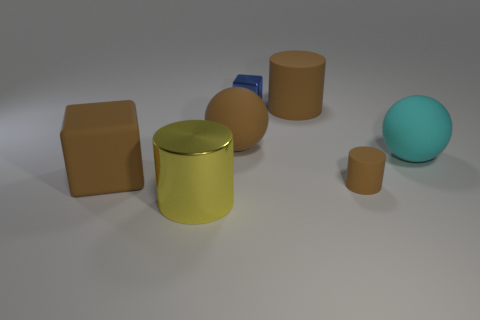Subtract all big cylinders. How many cylinders are left? 1 Subtract all gray blocks. How many brown cylinders are left? 2 Subtract 2 cubes. How many cubes are left? 0 Subtract all yellow cylinders. How many cylinders are left? 2 Add 2 metal cubes. How many objects exist? 9 Subtract all red cylinders. Subtract all purple blocks. How many cylinders are left? 3 Subtract all balls. How many objects are left? 5 Subtract all large yellow shiny cylinders. Subtract all blue metal cubes. How many objects are left? 5 Add 3 small blocks. How many small blocks are left? 4 Add 5 blue things. How many blue things exist? 6 